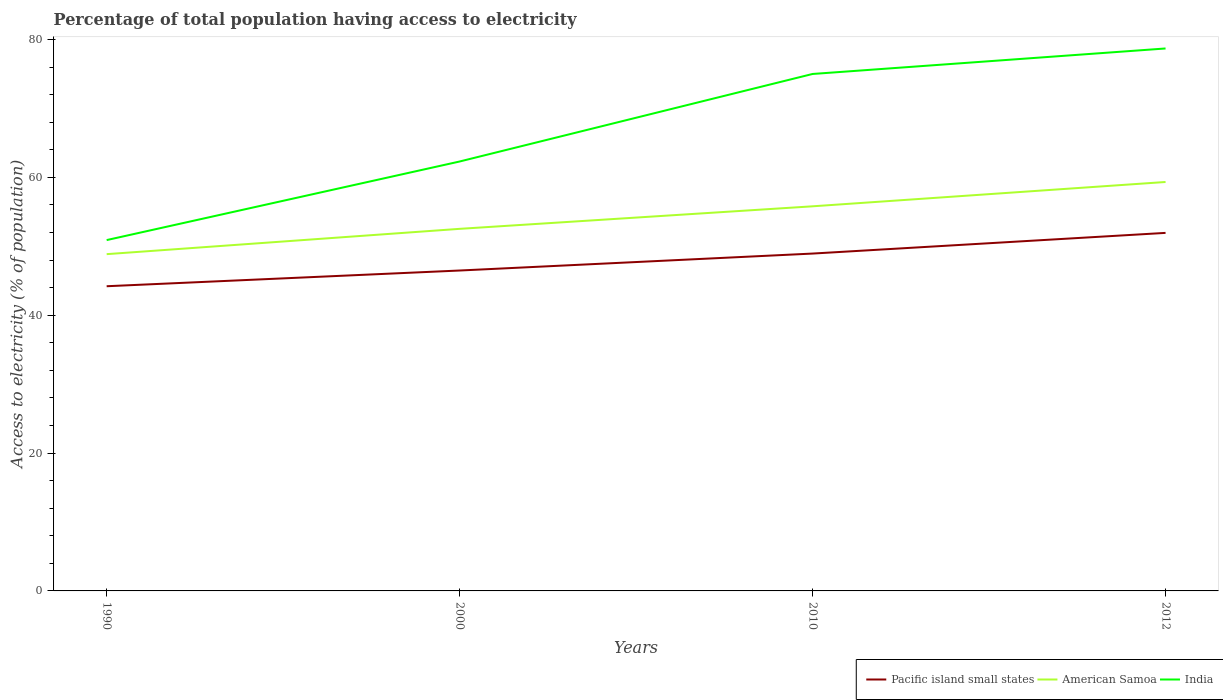Does the line corresponding to India intersect with the line corresponding to American Samoa?
Your answer should be compact. No. Across all years, what is the maximum percentage of population that have access to electricity in American Samoa?
Provide a short and direct response. 48.86. What is the total percentage of population that have access to electricity in India in the graph?
Offer a terse response. -11.4. What is the difference between the highest and the second highest percentage of population that have access to electricity in American Samoa?
Make the answer very short. 10.47. What is the difference between the highest and the lowest percentage of population that have access to electricity in American Samoa?
Provide a succinct answer. 2. Is the percentage of population that have access to electricity in American Samoa strictly greater than the percentage of population that have access to electricity in India over the years?
Give a very brief answer. Yes. How many years are there in the graph?
Give a very brief answer. 4. Where does the legend appear in the graph?
Make the answer very short. Bottom right. How many legend labels are there?
Provide a succinct answer. 3. How are the legend labels stacked?
Your response must be concise. Horizontal. What is the title of the graph?
Your answer should be compact. Percentage of total population having access to electricity. What is the label or title of the Y-axis?
Your answer should be very brief. Access to electricity (% of population). What is the Access to electricity (% of population) of Pacific island small states in 1990?
Provide a succinct answer. 44.2. What is the Access to electricity (% of population) in American Samoa in 1990?
Offer a very short reply. 48.86. What is the Access to electricity (% of population) in India in 1990?
Offer a very short reply. 50.9. What is the Access to electricity (% of population) of Pacific island small states in 2000?
Your answer should be compact. 46.48. What is the Access to electricity (% of population) of American Samoa in 2000?
Provide a succinct answer. 52.53. What is the Access to electricity (% of population) in India in 2000?
Ensure brevity in your answer.  62.3. What is the Access to electricity (% of population) in Pacific island small states in 2010?
Provide a succinct answer. 48.94. What is the Access to electricity (% of population) in American Samoa in 2010?
Make the answer very short. 55.8. What is the Access to electricity (% of population) of Pacific island small states in 2012?
Your answer should be compact. 51.94. What is the Access to electricity (% of population) in American Samoa in 2012?
Your response must be concise. 59.33. What is the Access to electricity (% of population) of India in 2012?
Make the answer very short. 78.7. Across all years, what is the maximum Access to electricity (% of population) of Pacific island small states?
Your answer should be compact. 51.94. Across all years, what is the maximum Access to electricity (% of population) of American Samoa?
Your answer should be compact. 59.33. Across all years, what is the maximum Access to electricity (% of population) of India?
Ensure brevity in your answer.  78.7. Across all years, what is the minimum Access to electricity (% of population) in Pacific island small states?
Your answer should be very brief. 44.2. Across all years, what is the minimum Access to electricity (% of population) of American Samoa?
Provide a short and direct response. 48.86. Across all years, what is the minimum Access to electricity (% of population) of India?
Your answer should be very brief. 50.9. What is the total Access to electricity (% of population) in Pacific island small states in the graph?
Make the answer very short. 191.58. What is the total Access to electricity (% of population) in American Samoa in the graph?
Provide a succinct answer. 216.52. What is the total Access to electricity (% of population) in India in the graph?
Make the answer very short. 266.9. What is the difference between the Access to electricity (% of population) of Pacific island small states in 1990 and that in 2000?
Offer a very short reply. -2.28. What is the difference between the Access to electricity (% of population) of American Samoa in 1990 and that in 2000?
Offer a very short reply. -3.67. What is the difference between the Access to electricity (% of population) in Pacific island small states in 1990 and that in 2010?
Make the answer very short. -4.74. What is the difference between the Access to electricity (% of population) in American Samoa in 1990 and that in 2010?
Your answer should be very brief. -6.94. What is the difference between the Access to electricity (% of population) in India in 1990 and that in 2010?
Provide a short and direct response. -24.1. What is the difference between the Access to electricity (% of population) of Pacific island small states in 1990 and that in 2012?
Provide a succinct answer. -7.74. What is the difference between the Access to electricity (% of population) in American Samoa in 1990 and that in 2012?
Your answer should be compact. -10.47. What is the difference between the Access to electricity (% of population) of India in 1990 and that in 2012?
Provide a succinct answer. -27.8. What is the difference between the Access to electricity (% of population) in Pacific island small states in 2000 and that in 2010?
Provide a succinct answer. -2.46. What is the difference between the Access to electricity (% of population) in American Samoa in 2000 and that in 2010?
Your response must be concise. -3.27. What is the difference between the Access to electricity (% of population) in India in 2000 and that in 2010?
Offer a terse response. -12.7. What is the difference between the Access to electricity (% of population) of Pacific island small states in 2000 and that in 2012?
Your answer should be very brief. -5.46. What is the difference between the Access to electricity (% of population) of American Samoa in 2000 and that in 2012?
Ensure brevity in your answer.  -6.8. What is the difference between the Access to electricity (% of population) of India in 2000 and that in 2012?
Your response must be concise. -16.4. What is the difference between the Access to electricity (% of population) of Pacific island small states in 2010 and that in 2012?
Offer a terse response. -3. What is the difference between the Access to electricity (% of population) in American Samoa in 2010 and that in 2012?
Your answer should be compact. -3.53. What is the difference between the Access to electricity (% of population) in Pacific island small states in 1990 and the Access to electricity (% of population) in American Samoa in 2000?
Provide a succinct answer. -8.33. What is the difference between the Access to electricity (% of population) in Pacific island small states in 1990 and the Access to electricity (% of population) in India in 2000?
Offer a terse response. -18.1. What is the difference between the Access to electricity (% of population) of American Samoa in 1990 and the Access to electricity (% of population) of India in 2000?
Give a very brief answer. -13.44. What is the difference between the Access to electricity (% of population) of Pacific island small states in 1990 and the Access to electricity (% of population) of American Samoa in 2010?
Make the answer very short. -11.6. What is the difference between the Access to electricity (% of population) in Pacific island small states in 1990 and the Access to electricity (% of population) in India in 2010?
Make the answer very short. -30.8. What is the difference between the Access to electricity (% of population) of American Samoa in 1990 and the Access to electricity (% of population) of India in 2010?
Your answer should be compact. -26.14. What is the difference between the Access to electricity (% of population) in Pacific island small states in 1990 and the Access to electricity (% of population) in American Samoa in 2012?
Ensure brevity in your answer.  -15.12. What is the difference between the Access to electricity (% of population) of Pacific island small states in 1990 and the Access to electricity (% of population) of India in 2012?
Offer a very short reply. -34.5. What is the difference between the Access to electricity (% of population) in American Samoa in 1990 and the Access to electricity (% of population) in India in 2012?
Keep it short and to the point. -29.84. What is the difference between the Access to electricity (% of population) of Pacific island small states in 2000 and the Access to electricity (% of population) of American Samoa in 2010?
Ensure brevity in your answer.  -9.32. What is the difference between the Access to electricity (% of population) in Pacific island small states in 2000 and the Access to electricity (% of population) in India in 2010?
Offer a very short reply. -28.52. What is the difference between the Access to electricity (% of population) of American Samoa in 2000 and the Access to electricity (% of population) of India in 2010?
Your answer should be compact. -22.47. What is the difference between the Access to electricity (% of population) in Pacific island small states in 2000 and the Access to electricity (% of population) in American Samoa in 2012?
Provide a succinct answer. -12.84. What is the difference between the Access to electricity (% of population) of Pacific island small states in 2000 and the Access to electricity (% of population) of India in 2012?
Make the answer very short. -32.22. What is the difference between the Access to electricity (% of population) of American Samoa in 2000 and the Access to electricity (% of population) of India in 2012?
Make the answer very short. -26.17. What is the difference between the Access to electricity (% of population) in Pacific island small states in 2010 and the Access to electricity (% of population) in American Samoa in 2012?
Make the answer very short. -10.39. What is the difference between the Access to electricity (% of population) of Pacific island small states in 2010 and the Access to electricity (% of population) of India in 2012?
Ensure brevity in your answer.  -29.76. What is the difference between the Access to electricity (% of population) in American Samoa in 2010 and the Access to electricity (% of population) in India in 2012?
Your response must be concise. -22.9. What is the average Access to electricity (% of population) of Pacific island small states per year?
Give a very brief answer. 47.89. What is the average Access to electricity (% of population) in American Samoa per year?
Offer a very short reply. 54.13. What is the average Access to electricity (% of population) of India per year?
Ensure brevity in your answer.  66.72. In the year 1990, what is the difference between the Access to electricity (% of population) of Pacific island small states and Access to electricity (% of population) of American Samoa?
Provide a short and direct response. -4.65. In the year 1990, what is the difference between the Access to electricity (% of population) in Pacific island small states and Access to electricity (% of population) in India?
Your answer should be compact. -6.7. In the year 1990, what is the difference between the Access to electricity (% of population) of American Samoa and Access to electricity (% of population) of India?
Your response must be concise. -2.04. In the year 2000, what is the difference between the Access to electricity (% of population) in Pacific island small states and Access to electricity (% of population) in American Samoa?
Ensure brevity in your answer.  -6.05. In the year 2000, what is the difference between the Access to electricity (% of population) of Pacific island small states and Access to electricity (% of population) of India?
Keep it short and to the point. -15.82. In the year 2000, what is the difference between the Access to electricity (% of population) in American Samoa and Access to electricity (% of population) in India?
Provide a short and direct response. -9.77. In the year 2010, what is the difference between the Access to electricity (% of population) of Pacific island small states and Access to electricity (% of population) of American Samoa?
Provide a short and direct response. -6.86. In the year 2010, what is the difference between the Access to electricity (% of population) of Pacific island small states and Access to electricity (% of population) of India?
Ensure brevity in your answer.  -26.06. In the year 2010, what is the difference between the Access to electricity (% of population) of American Samoa and Access to electricity (% of population) of India?
Your answer should be very brief. -19.2. In the year 2012, what is the difference between the Access to electricity (% of population) in Pacific island small states and Access to electricity (% of population) in American Samoa?
Your response must be concise. -7.38. In the year 2012, what is the difference between the Access to electricity (% of population) of Pacific island small states and Access to electricity (% of population) of India?
Offer a very short reply. -26.76. In the year 2012, what is the difference between the Access to electricity (% of population) of American Samoa and Access to electricity (% of population) of India?
Ensure brevity in your answer.  -19.37. What is the ratio of the Access to electricity (% of population) of Pacific island small states in 1990 to that in 2000?
Provide a short and direct response. 0.95. What is the ratio of the Access to electricity (% of population) in American Samoa in 1990 to that in 2000?
Keep it short and to the point. 0.93. What is the ratio of the Access to electricity (% of population) in India in 1990 to that in 2000?
Offer a terse response. 0.82. What is the ratio of the Access to electricity (% of population) in Pacific island small states in 1990 to that in 2010?
Provide a short and direct response. 0.9. What is the ratio of the Access to electricity (% of population) of American Samoa in 1990 to that in 2010?
Your answer should be very brief. 0.88. What is the ratio of the Access to electricity (% of population) in India in 1990 to that in 2010?
Keep it short and to the point. 0.68. What is the ratio of the Access to electricity (% of population) in Pacific island small states in 1990 to that in 2012?
Make the answer very short. 0.85. What is the ratio of the Access to electricity (% of population) of American Samoa in 1990 to that in 2012?
Keep it short and to the point. 0.82. What is the ratio of the Access to electricity (% of population) of India in 1990 to that in 2012?
Give a very brief answer. 0.65. What is the ratio of the Access to electricity (% of population) in Pacific island small states in 2000 to that in 2010?
Your response must be concise. 0.95. What is the ratio of the Access to electricity (% of population) in American Samoa in 2000 to that in 2010?
Provide a short and direct response. 0.94. What is the ratio of the Access to electricity (% of population) in India in 2000 to that in 2010?
Ensure brevity in your answer.  0.83. What is the ratio of the Access to electricity (% of population) of Pacific island small states in 2000 to that in 2012?
Your answer should be compact. 0.89. What is the ratio of the Access to electricity (% of population) in American Samoa in 2000 to that in 2012?
Offer a terse response. 0.89. What is the ratio of the Access to electricity (% of population) in India in 2000 to that in 2012?
Your answer should be compact. 0.79. What is the ratio of the Access to electricity (% of population) in Pacific island small states in 2010 to that in 2012?
Keep it short and to the point. 0.94. What is the ratio of the Access to electricity (% of population) in American Samoa in 2010 to that in 2012?
Your answer should be very brief. 0.94. What is the ratio of the Access to electricity (% of population) of India in 2010 to that in 2012?
Make the answer very short. 0.95. What is the difference between the highest and the second highest Access to electricity (% of population) of Pacific island small states?
Your answer should be very brief. 3. What is the difference between the highest and the second highest Access to electricity (% of population) in American Samoa?
Offer a very short reply. 3.53. What is the difference between the highest and the second highest Access to electricity (% of population) in India?
Ensure brevity in your answer.  3.7. What is the difference between the highest and the lowest Access to electricity (% of population) of Pacific island small states?
Your answer should be very brief. 7.74. What is the difference between the highest and the lowest Access to electricity (% of population) in American Samoa?
Provide a short and direct response. 10.47. What is the difference between the highest and the lowest Access to electricity (% of population) of India?
Your answer should be compact. 27.8. 